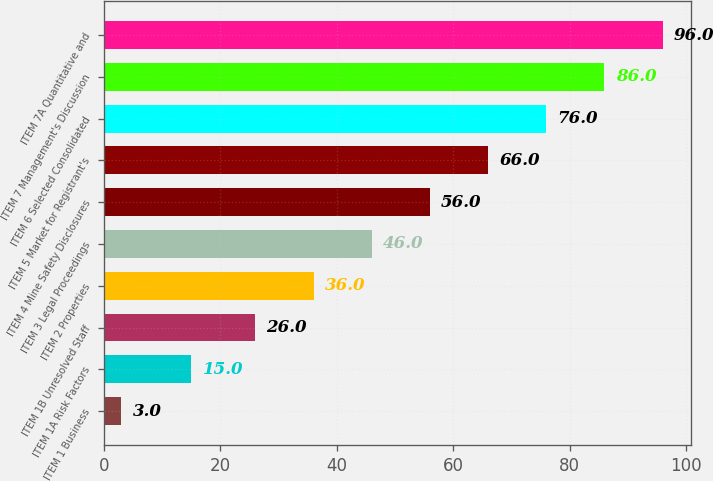Convert chart to OTSL. <chart><loc_0><loc_0><loc_500><loc_500><bar_chart><fcel>ITEM 1 Business<fcel>ITEM 1A Risk Factors<fcel>ITEM 1B Unresolved Staff<fcel>ITEM 2 Properties<fcel>ITEM 3 Legal Proceedings<fcel>ITEM 4 Mine Safety Disclosures<fcel>ITEM 5 Market for Registrant's<fcel>ITEM 6 Selected Consolidated<fcel>ITEM 7 Management's Discussion<fcel>ITEM 7A Quantitative and<nl><fcel>3<fcel>15<fcel>26<fcel>36<fcel>46<fcel>56<fcel>66<fcel>76<fcel>86<fcel>96<nl></chart> 